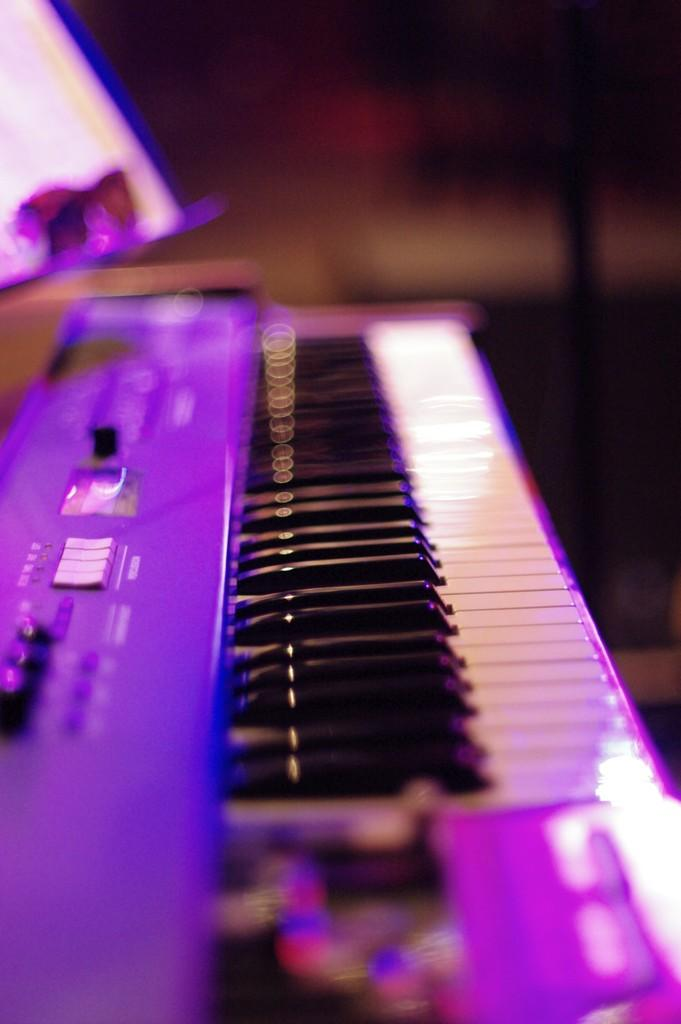What is the main object in the image? There is a piano in the image. What type of musical instrument is the piano? The piano is a keyboard instrument. Can you describe the appearance of the piano in the image? The image shows a piano with a keyboard and a wooden body. What color is the sock draped over the frame of the piano in the image? There is no sock or frame present in the image; it only features a piano. 